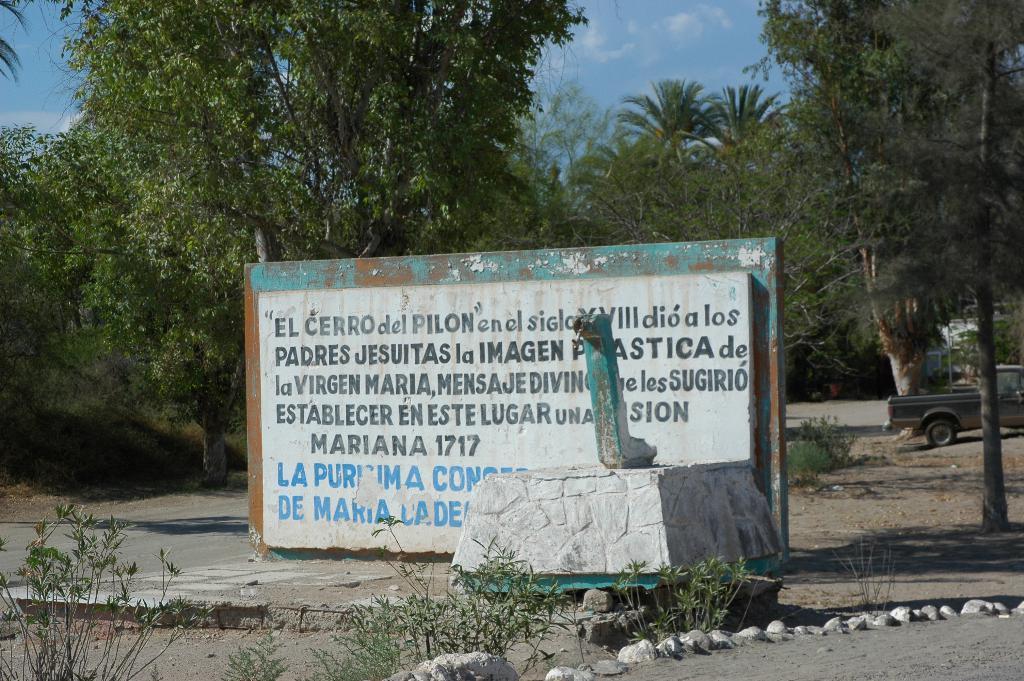Describe this image in one or two sentences. In this image we can see some trees, plants, rocks, there is a board with some text written on it, and there is an object on a concrete surface, and we can see a vehicle, and the sky. 